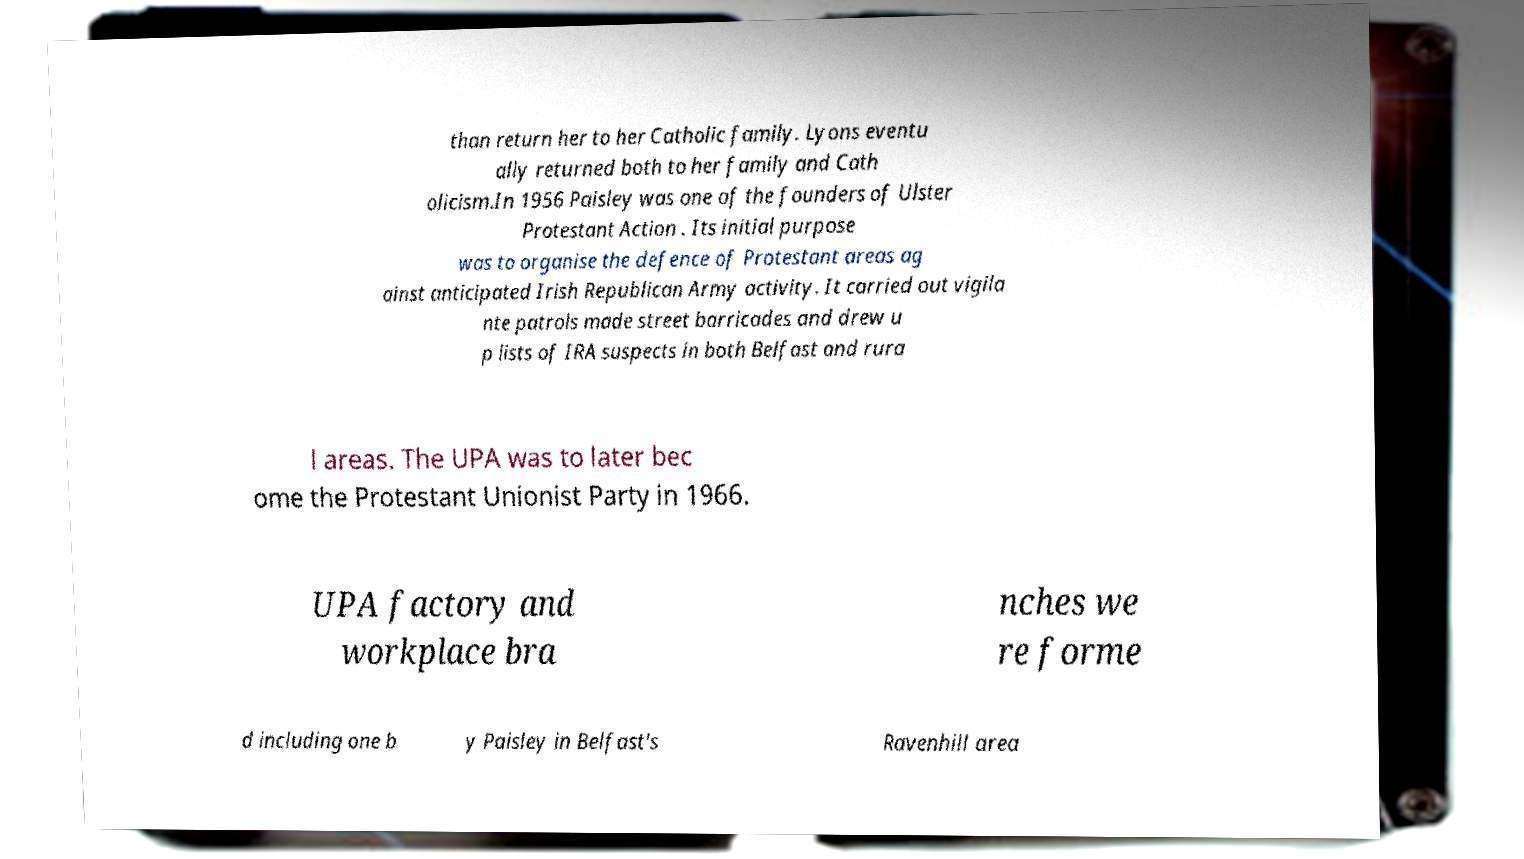There's text embedded in this image that I need extracted. Can you transcribe it verbatim? than return her to her Catholic family. Lyons eventu ally returned both to her family and Cath olicism.In 1956 Paisley was one of the founders of Ulster Protestant Action . Its initial purpose was to organise the defence of Protestant areas ag ainst anticipated Irish Republican Army activity. It carried out vigila nte patrols made street barricades and drew u p lists of IRA suspects in both Belfast and rura l areas. The UPA was to later bec ome the Protestant Unionist Party in 1966. UPA factory and workplace bra nches we re forme d including one b y Paisley in Belfast's Ravenhill area 